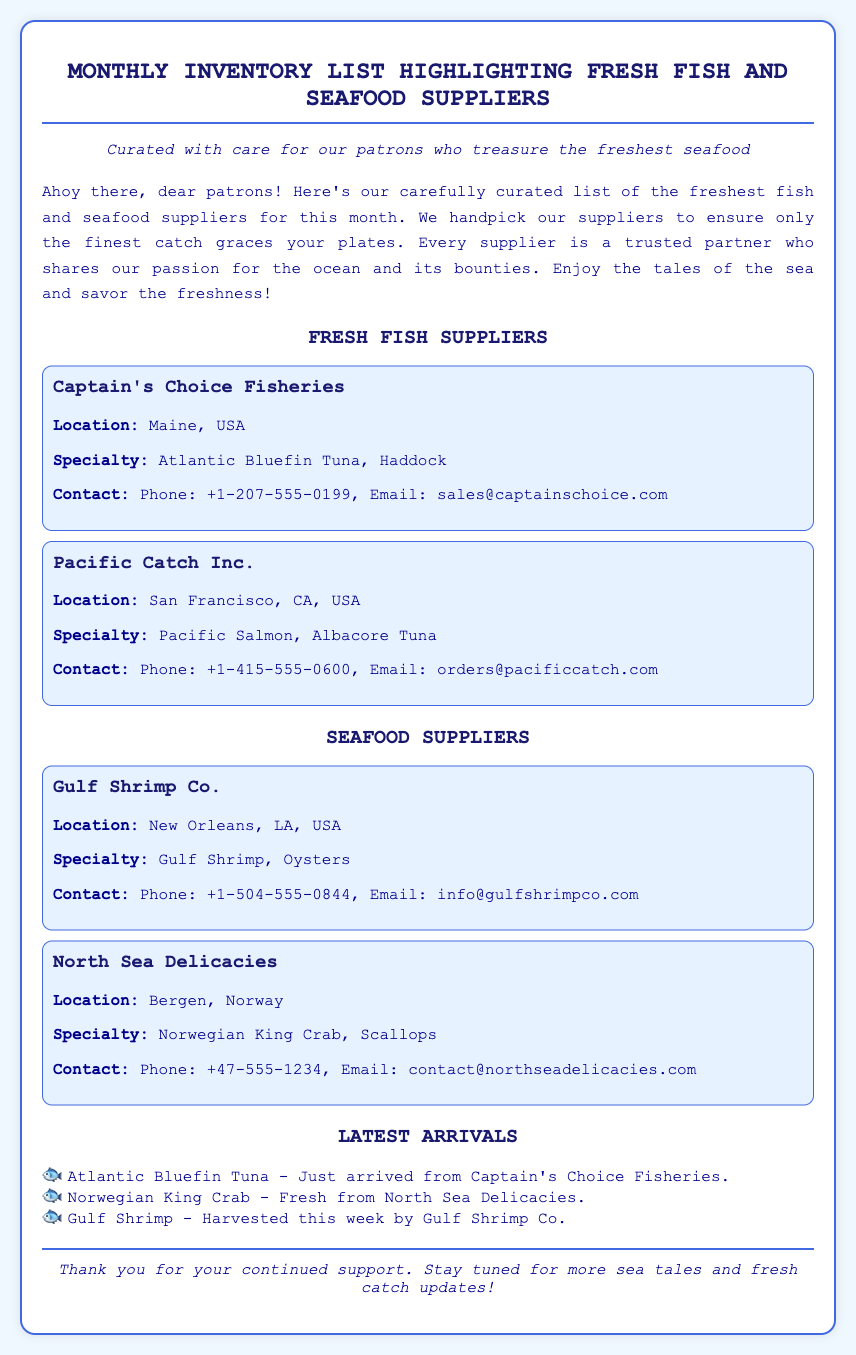What is the title of the document? The title is located at the top of the document and provides a clear indication of its content.
Answer: Monthly Inventory List Highlighting Fresh Fish and Seafood Suppliers Who is the supplier from Maine, USA? The supplier's location is mentioned next to its name in the document, identifying its place of origin.
Answer: Captain's Choice Fisheries What specialty does Gulf Shrimp Co. offer? The document specifies the specialties of each supplier, detailing their main products.
Answer: Gulf Shrimp, Oysters How many suppliers are listed under Fresh Fish? The total count of suppliers is provided by viewing the sections and counting the suppliers mentioned.
Answer: 2 Where is North Sea Delicacies located? The location of North Sea Delicacies is explicitly mentioned in the supplier information section of the document.
Answer: Bergen, Norway Which seafood was harvested this week according to the Latest Arrivals? The document mentions specifics about the latest arrivals, including their freshness and source.
Answer: Gulf Shrimp What is the contact email for Pacific Catch Inc.? The contact information for suppliers includes email addresses for easy communication, as listed.
Answer: orders@pacificcatch.com What item just arrived from Captain's Choice Fisheries? The Latest Arrivals section highlights specific products associated with their suppliers, indicating freshness.
Answer: Atlantic Bluefin Tuna Which company specializes in Norwegian King Crab? The specialties section directly states which supplier deals with Norwegian King Crab among their offerings.
Answer: North Sea Delicacies 